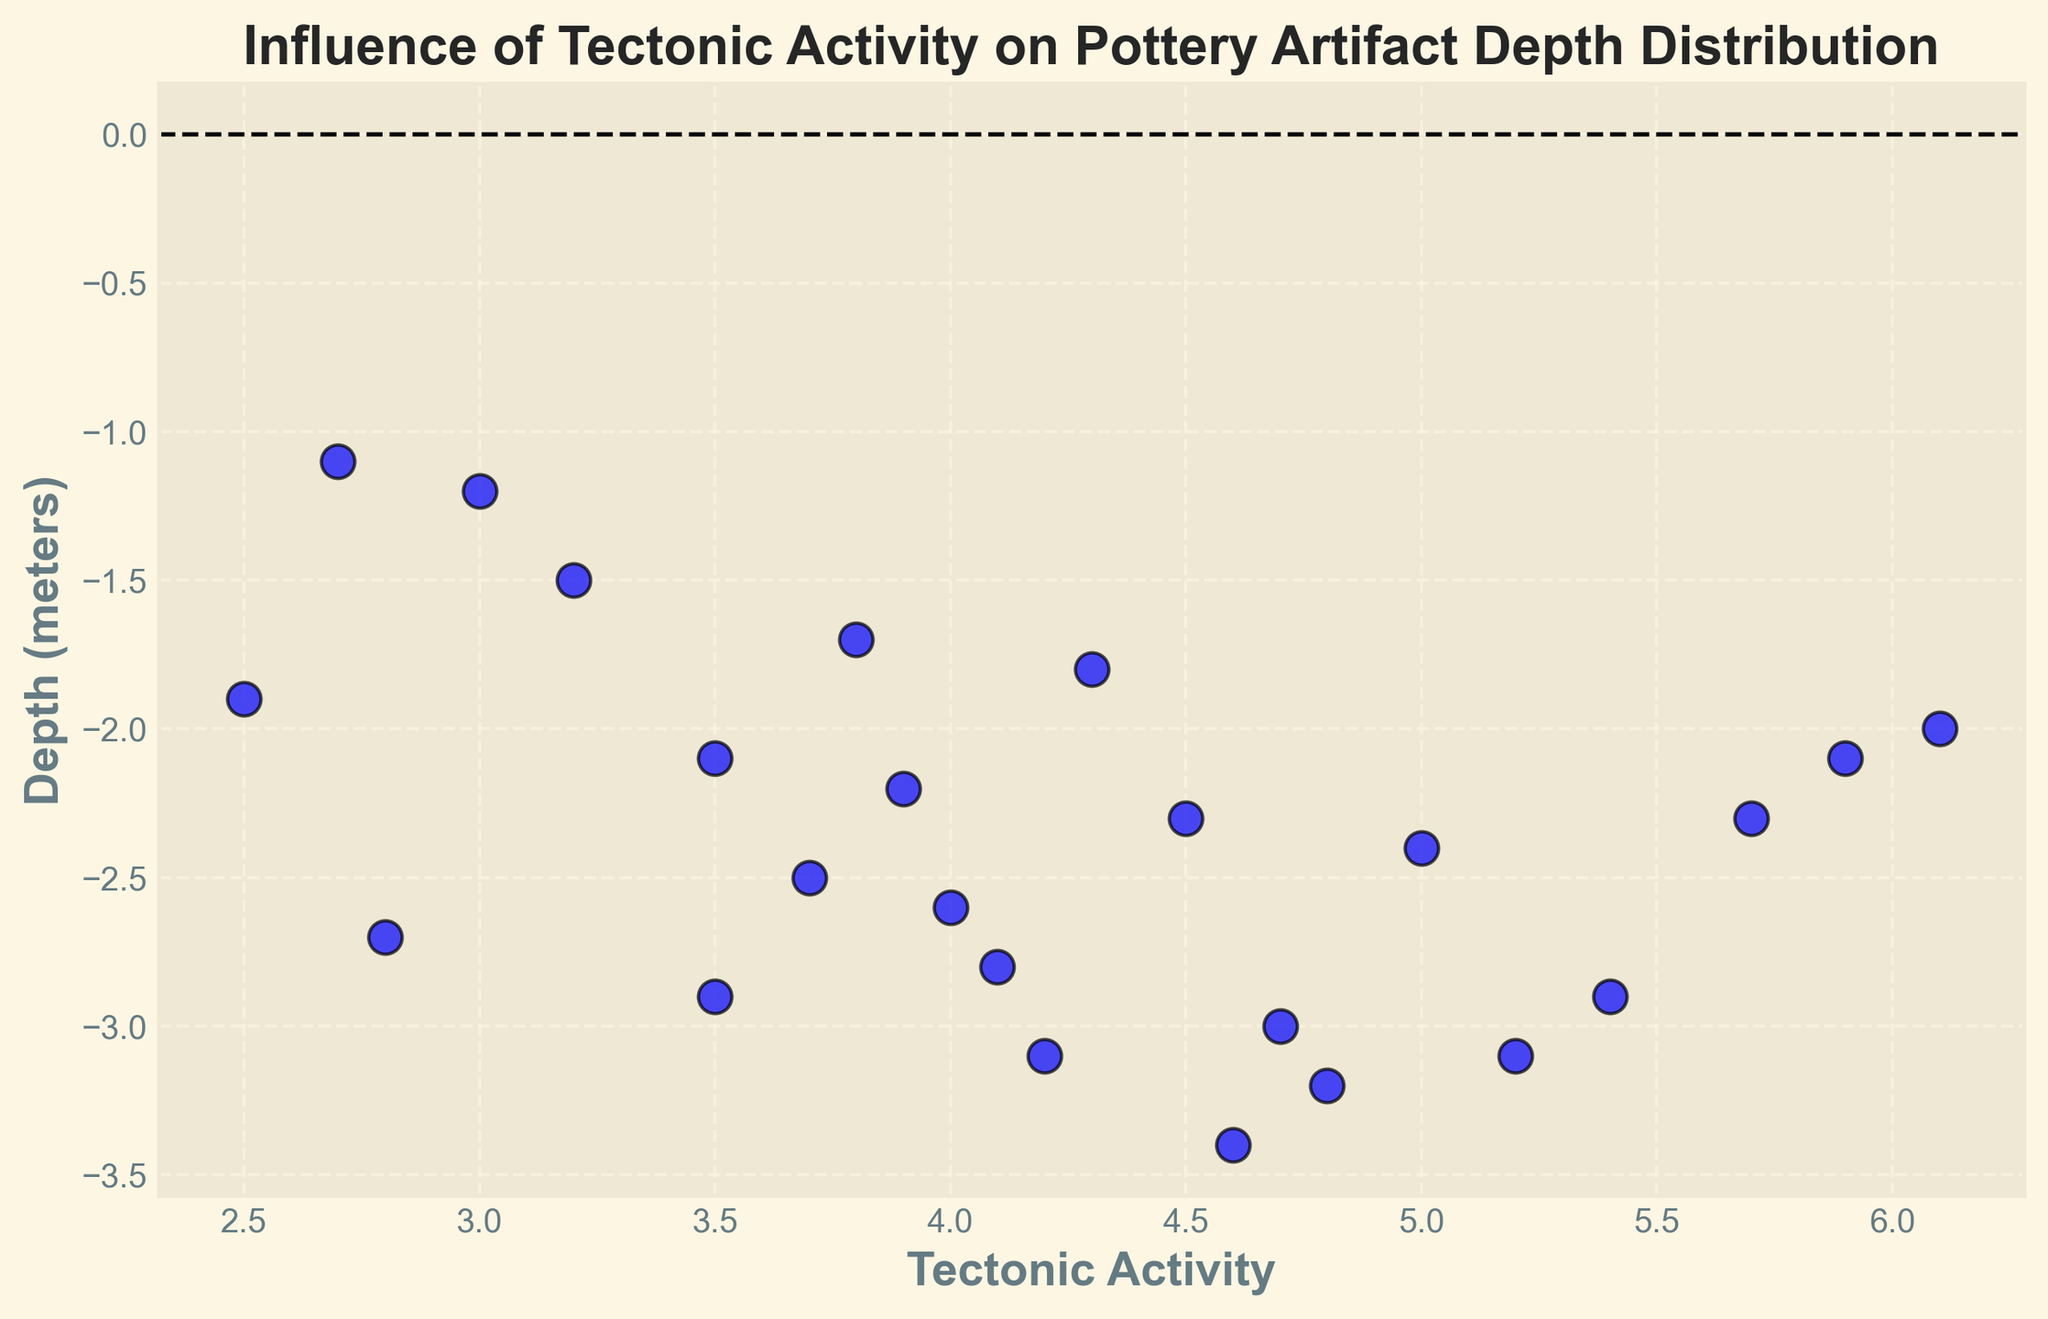What general trend can be observed between tectonic activity and the depth of pottery artifacts? By observing the scatter plot, you can see a general trend where higher tectonic activity tends to correlate with deeper depths of pottery artifacts. This can be inferred from the clustered points.
Answer: Higher tectonic activity correlates with deeper depths Which site has the highest tectonic activity and what is the depth of pottery artifacts at that site? The highest tectonic activity value on the x-axis is 6.1. The corresponding depth value (y-axis) is around -2.0 meters.
Answer: Depth is around -2.0 meters What is the average depth of pottery artifacts with a tectonic activity level of 4.5? There is only one data point with tectonic activity level 4.5, which has a depth of -2.3 meters. Therefore, the average depth would be the same as this single depth value.
Answer: -2.3 meters Which two sites have tectonic activity levels of 5.2 and 3.0, and what are their corresponding depths? For tectonic activity 5.2, the depth is around -3.1 meters. For tectonic activity 3.0, the depth is around -1.2 meters. These values can be identified by locating the specific x-axis values and then reading the corresponding y-axis values.
Answer: Depths are -3.1 meters and -1.2 meters, respectively Which site shows the deepest depth of pottery artifacts and what is its tectonic activity level? The deepest depth is identified as -3.4 meters by locating the lowest point on the y-axis. The corresponding tectonic activity level is around 4.6.
Answer: Tectonic activity level is around 4.6 Is there a site where shallow depths of pottery artifacts are associated with high tectonic activity? Shallow depths (closer to 0 on the y-axis) and high tectonic activity (farther on the x-axis) do not seem to overlap much.
Answer: No What is the range of tectonic activity levels for depths between -2.0 and -3.0 meters? Observing the y-axis range between -2.0 and -3.0 meters, the tectonic activity levels range from approximately 3.5 to 5.2 on the x-axis.
Answer: Approximately 3.5 to 5.2 Do any sites have both low tectonic activity and shallow depths? Low tectonic activity (near the origin on the x-axis) and shallow depths (closer to 0 on the y-axis) do not overlap, indicating no such sites in the data.
Answer: None What is the average tectonic activity of all sites combined? Sum all tectonic activity levels and divide by the number of data points: (4.5 + 5.2 + 3.8 + 6.1 + 2.5 + 3.7 + 4.1 + 4.8 + 5.9 + 3.0 + 4.7 + 4.0 + 4.3 + 5.0 + 2.8 + 3.5 + 3.2 + 3.9 + 2.7 + 4.6 + 5.4 + 3.5 + 4.2 + 5.7) / 24.
Answer: Approximately 4.2 How many sites have depths less than -3.0 meters? By counting the points on the y-axis below -3.0, there are three such sites. This count can be derived by visually inspecting the y-axis.
Answer: Three sites 